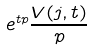<formula> <loc_0><loc_0><loc_500><loc_500>e ^ { t p } \frac { V ( j , t ) } { p }</formula> 